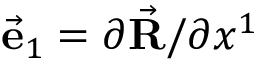<formula> <loc_0><loc_0><loc_500><loc_500>\vec { e } _ { 1 } = \partial \vec { R } / \partial x ^ { 1 }</formula> 